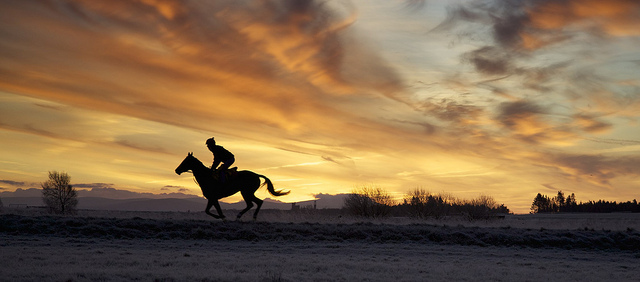How many real live dogs are in the photo? 0 